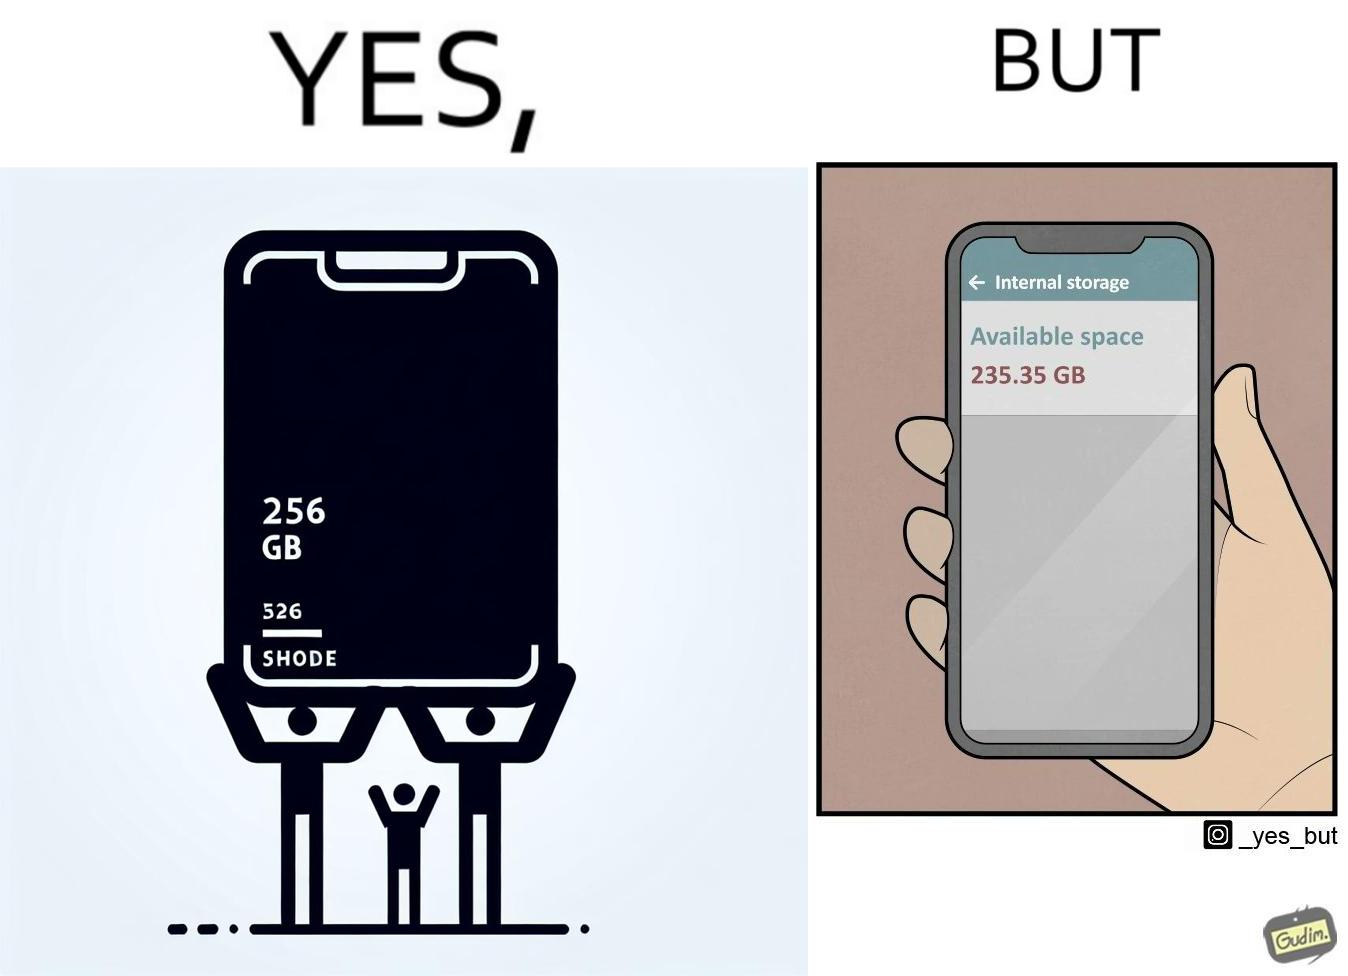Describe the satirical element in this image. The images are funny since they show how smartphone manufacturers advertise their smartphones to have a high internal storage space but in reality, the amount of space available to an user is considerably less due to pre-installed software 